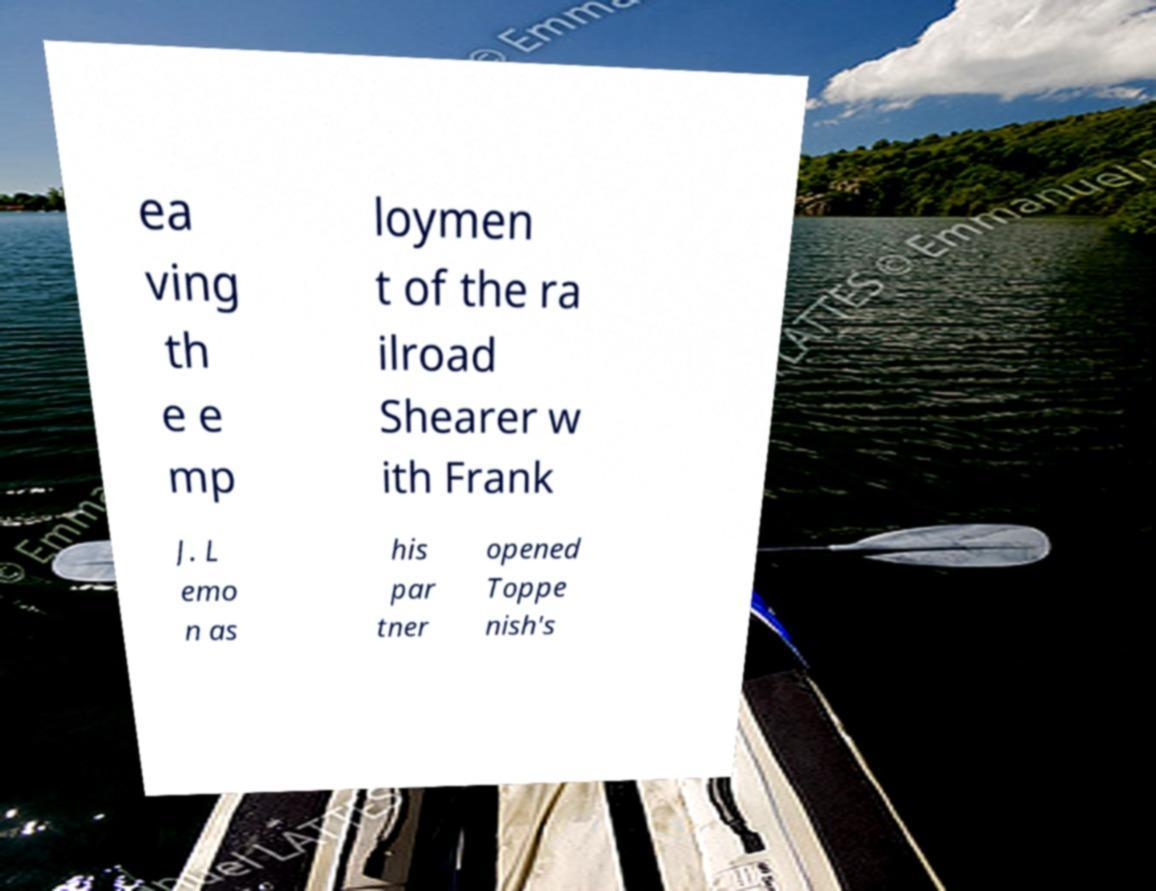Could you extract and type out the text from this image? ea ving th e e mp loymen t of the ra ilroad Shearer w ith Frank J. L emo n as his par tner opened Toppe nish's 